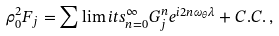Convert formula to latex. <formula><loc_0><loc_0><loc_500><loc_500>\rho _ { 0 } ^ { 2 } F _ { j } = \sum \lim i t s _ { n = 0 } ^ { \infty } { G _ { j } ^ { n } e ^ { i 2 n \omega _ { \theta } \lambda } } + C . C . \, ,</formula> 